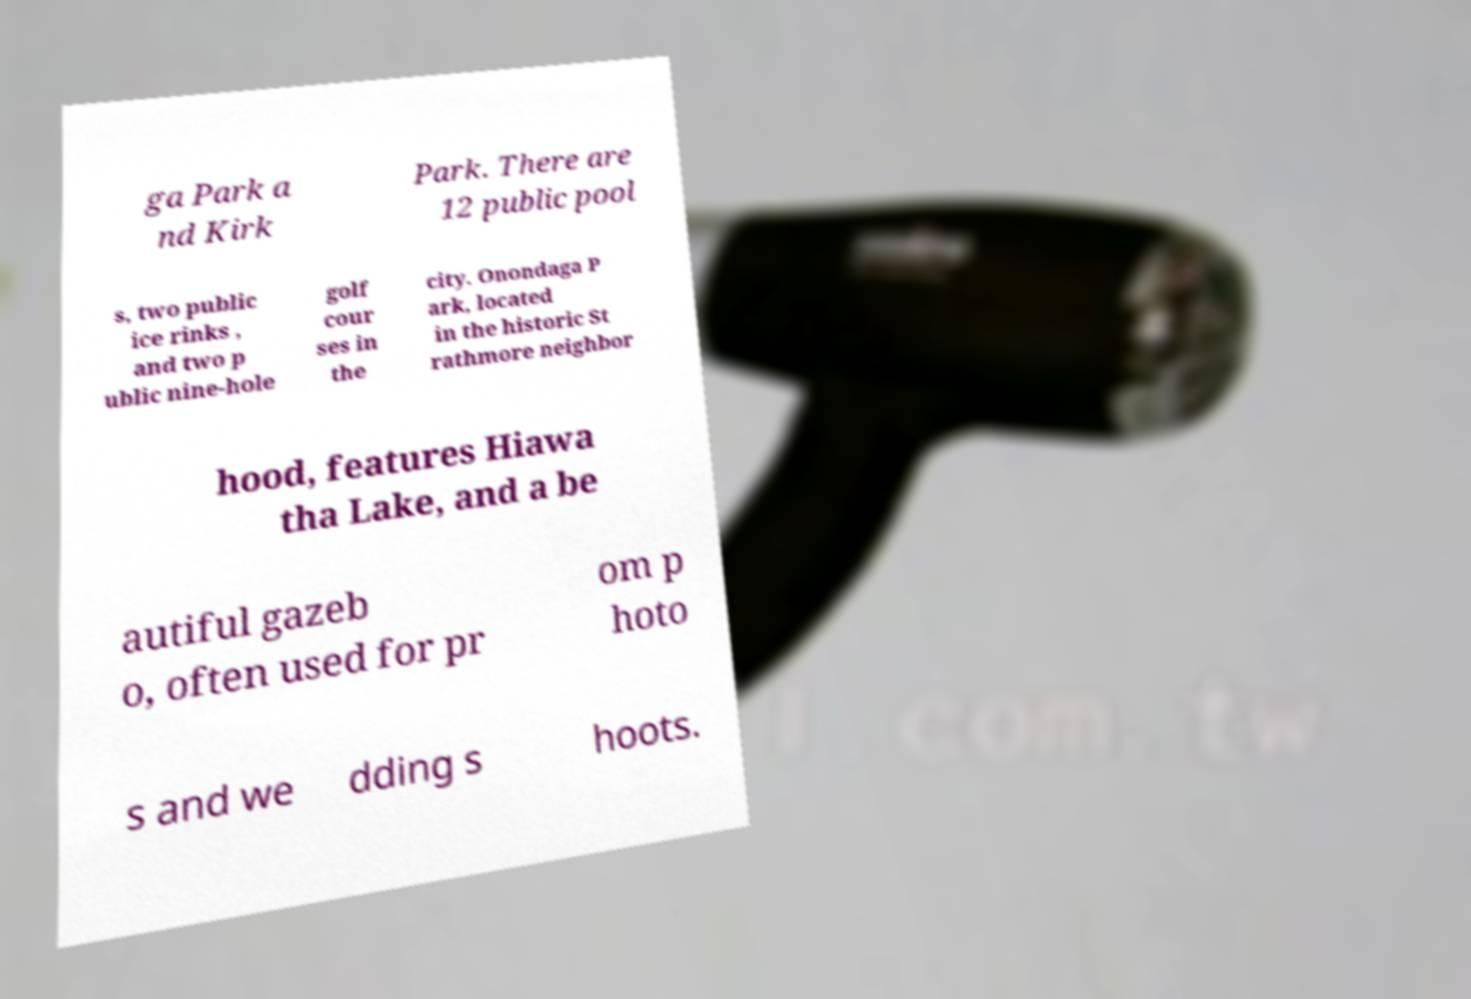Could you extract and type out the text from this image? ga Park a nd Kirk Park. There are 12 public pool s, two public ice rinks , and two p ublic nine-hole golf cour ses in the city. Onondaga P ark, located in the historic St rathmore neighbor hood, features Hiawa tha Lake, and a be autiful gazeb o, often used for pr om p hoto s and we dding s hoots. 